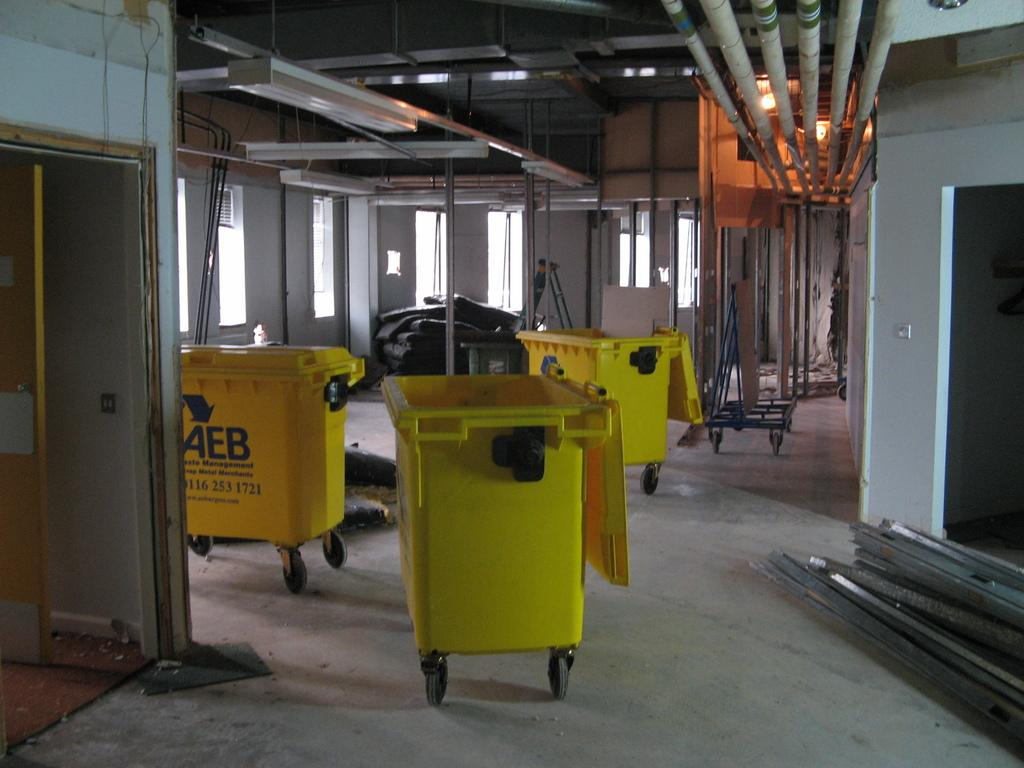Provide a one-sentence caption for the provided image. AEB are the letters on the yellow item. 